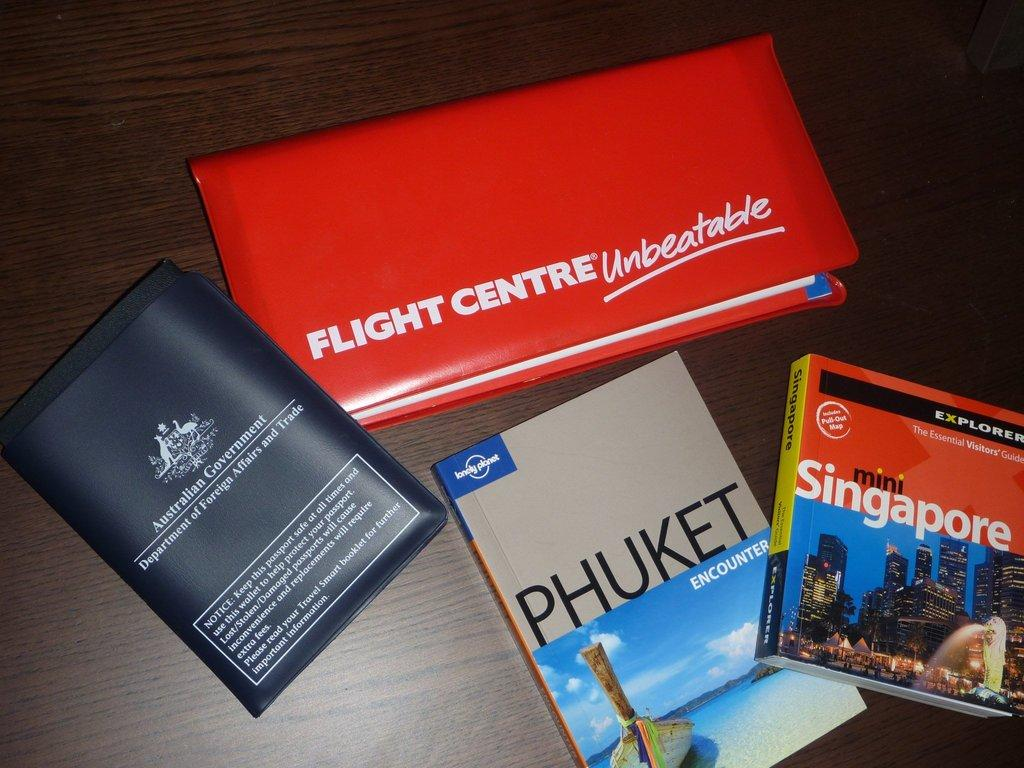<image>
Share a concise interpretation of the image provided. Books about Singapore and Phuket are among the items sitting on a table 